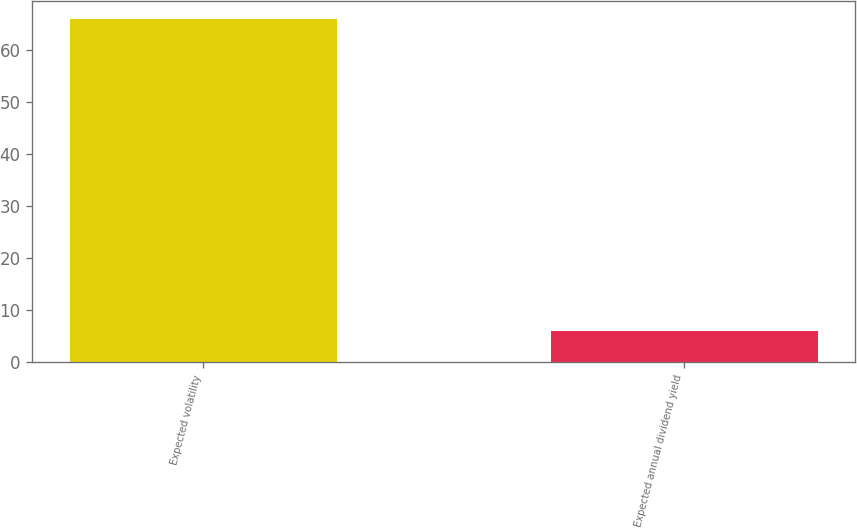<chart> <loc_0><loc_0><loc_500><loc_500><bar_chart><fcel>Expected volatility<fcel>Expected annual dividend yield<nl><fcel>66<fcel>6<nl></chart> 